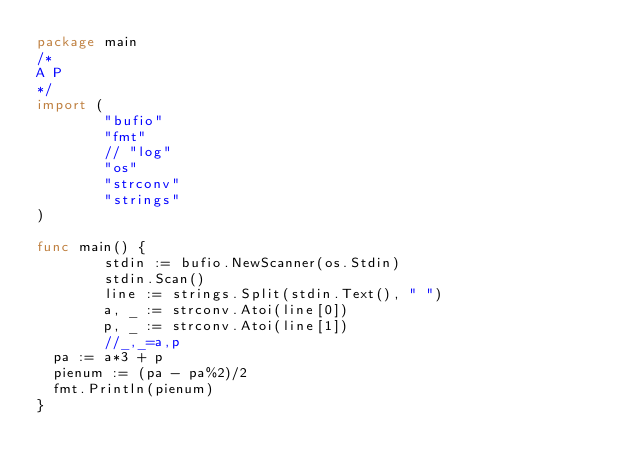<code> <loc_0><loc_0><loc_500><loc_500><_Go_>package main
/*
A P
*/
import (
        "bufio"
        "fmt"
        // "log"
        "os"
        "strconv"
        "strings"
)

func main() {
        stdin := bufio.NewScanner(os.Stdin)
        stdin.Scan()
        line := strings.Split(stdin.Text(), " ")
        a, _ := strconv.Atoi(line[0])
        p, _ := strconv.Atoi(line[1])
        //_,_=a,p
	pa := a*3 + p
	pienum := (pa - pa%2)/2
	fmt.Println(pienum)
}
</code> 